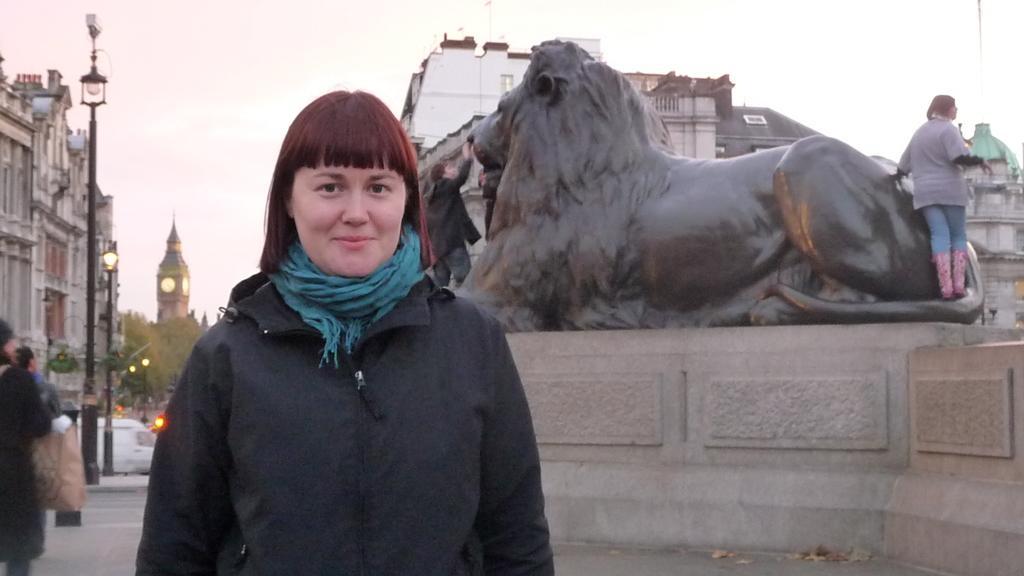Describe this image in one or two sentences. In this picture we can see a woman wearing black coat, blue muffler and standing in front and smiling. Behind there is a lion statue and a man standing beside the statue. On the left side there is a building, lamppost and clock tower. 